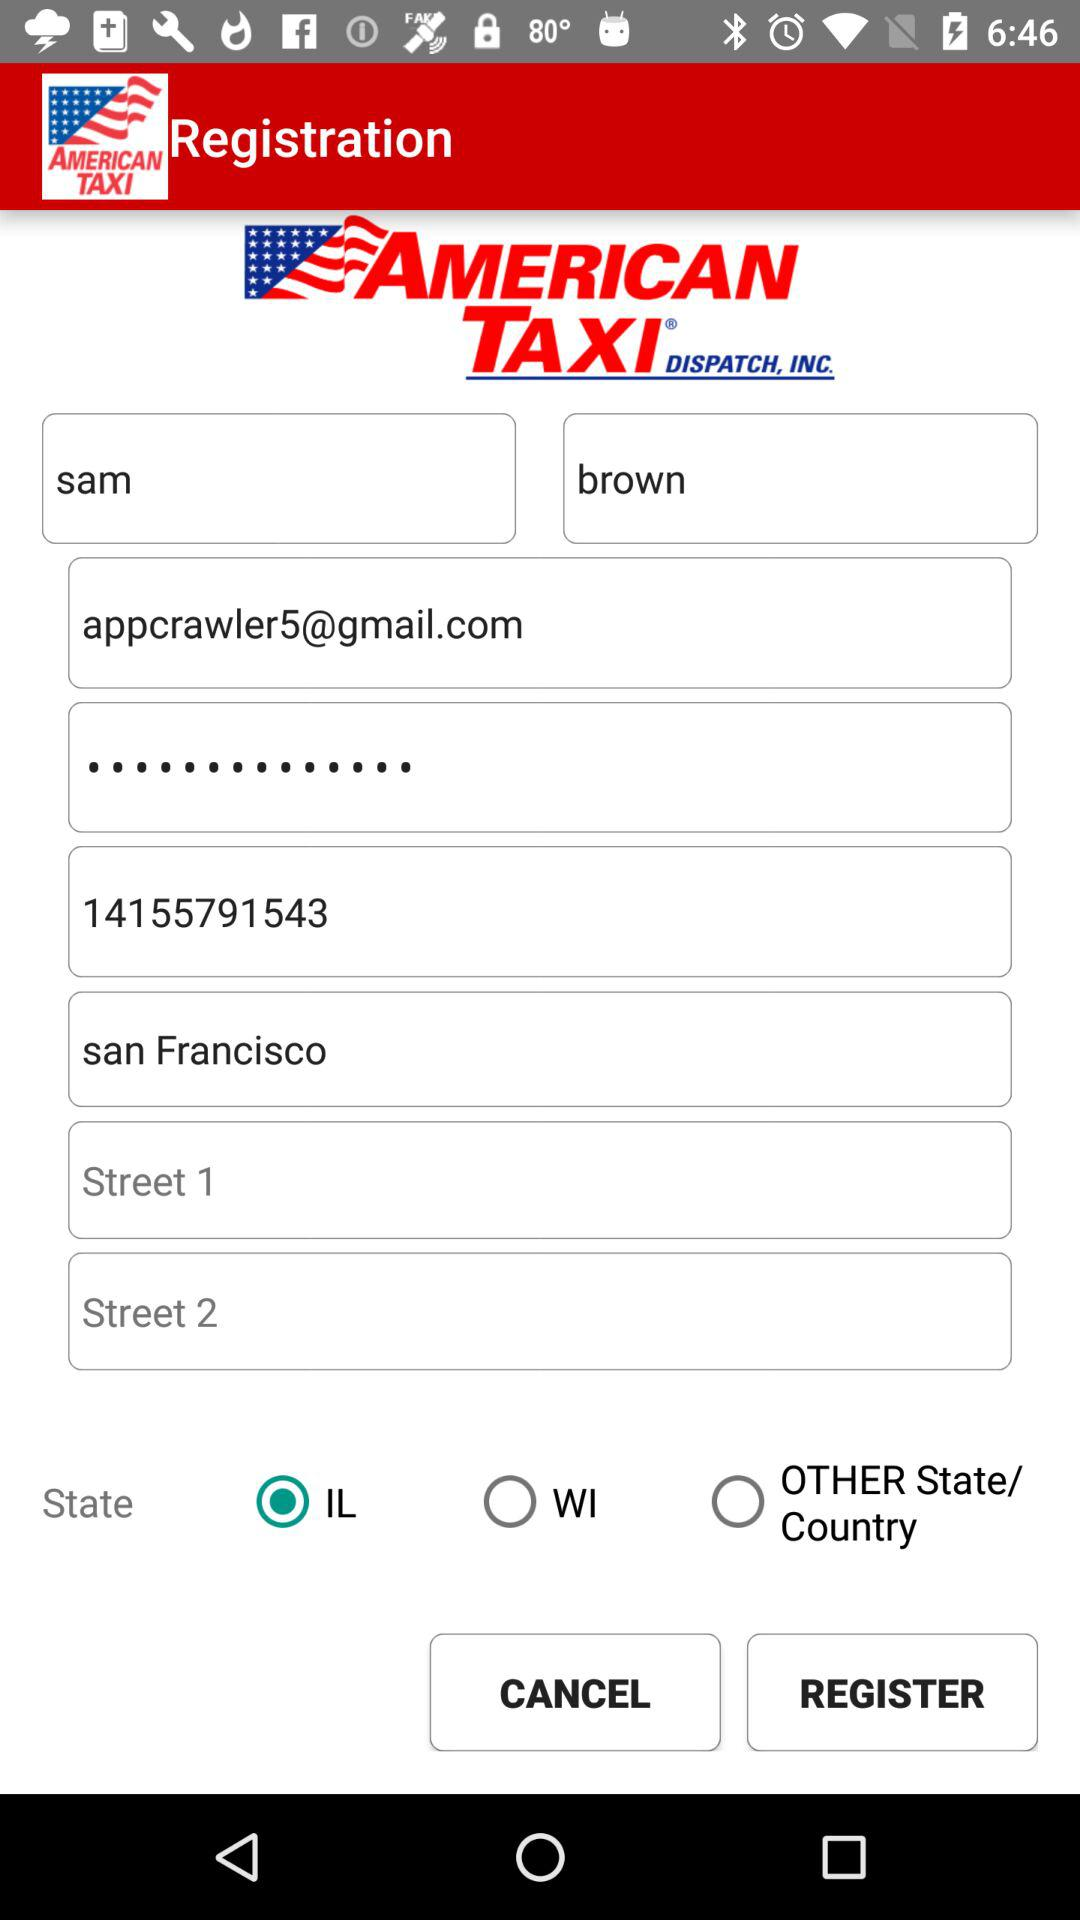What is the email address? The email address is appcrawler5@gmail.com. 